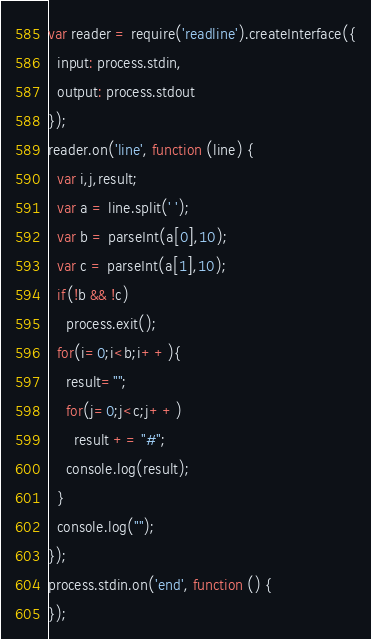Convert code to text. <code><loc_0><loc_0><loc_500><loc_500><_JavaScript_>var reader = require('readline').createInterface({
  input: process.stdin,
  output: process.stdout
});
reader.on('line', function (line) {
  var i,j,result;
  var a = line.split(' ');
  var b = parseInt(a[0],10);
  var c = parseInt(a[1],10);
  if(!b && !c)
    process.exit();
  for(i=0;i<b;i++){
    result="";
    for(j=0;j<c;j++)
      result += "#";
    console.log(result);
  }
  console.log("");
});
process.stdin.on('end', function () {
});</code> 